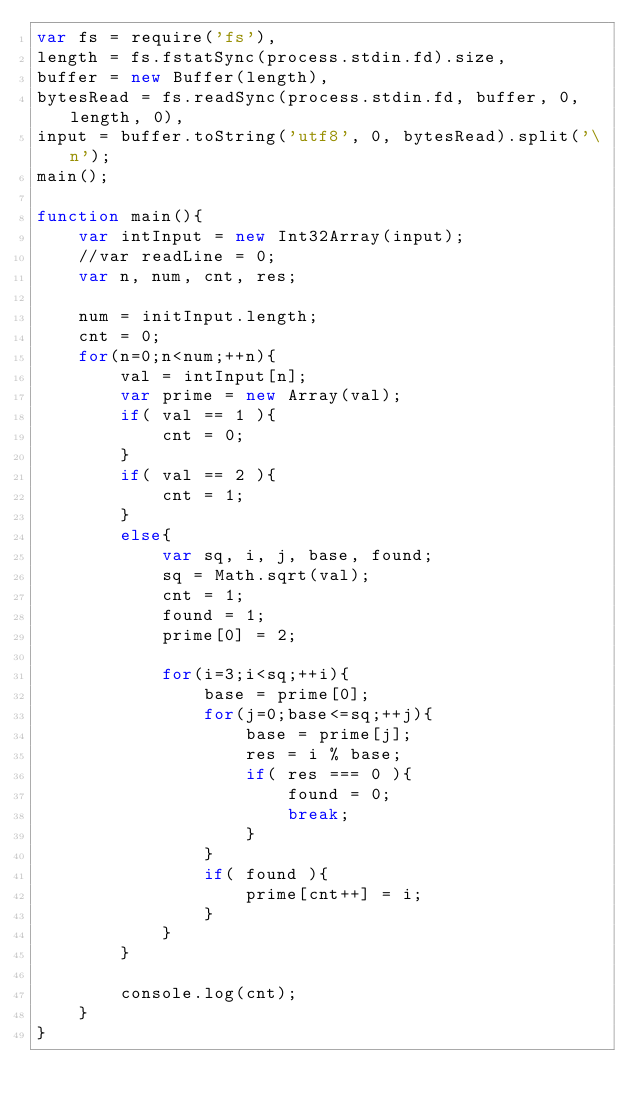Convert code to text. <code><loc_0><loc_0><loc_500><loc_500><_JavaScript_>var fs = require('fs'),
length = fs.fstatSync(process.stdin.fd).size,
buffer = new Buffer(length),
bytesRead = fs.readSync(process.stdin.fd, buffer, 0, length, 0),
input = buffer.toString('utf8', 0, bytesRead).split('\n');
main();

function main(){
    var intInput = new Int32Array(input);
    //var readLine = 0;
    var n, num, cnt, res;
    
    num = initInput.length;
    cnt = 0;
    for(n=0;n<num;++n){
        val = intInput[n];
        var prime = new Array(val);
        if( val == 1 ){
            cnt = 0;
        }
        if( val == 2 ){
            cnt = 1;
        }
        else{
            var sq, i, j, base, found;
            sq = Math.sqrt(val);
            cnt = 1;
            found = 1;
            prime[0] = 2;
            
            for(i=3;i<sq;++i){
                base = prime[0];
                for(j=0;base<=sq;++j){
                    base = prime[j];
                    res = i % base;
                    if( res === 0 ){
                        found = 0;
                        break;
                    }
                }
                if( found ){
                    prime[cnt++] = i;
                }
            }
        }
        
        console.log(cnt);
    }
}</code> 